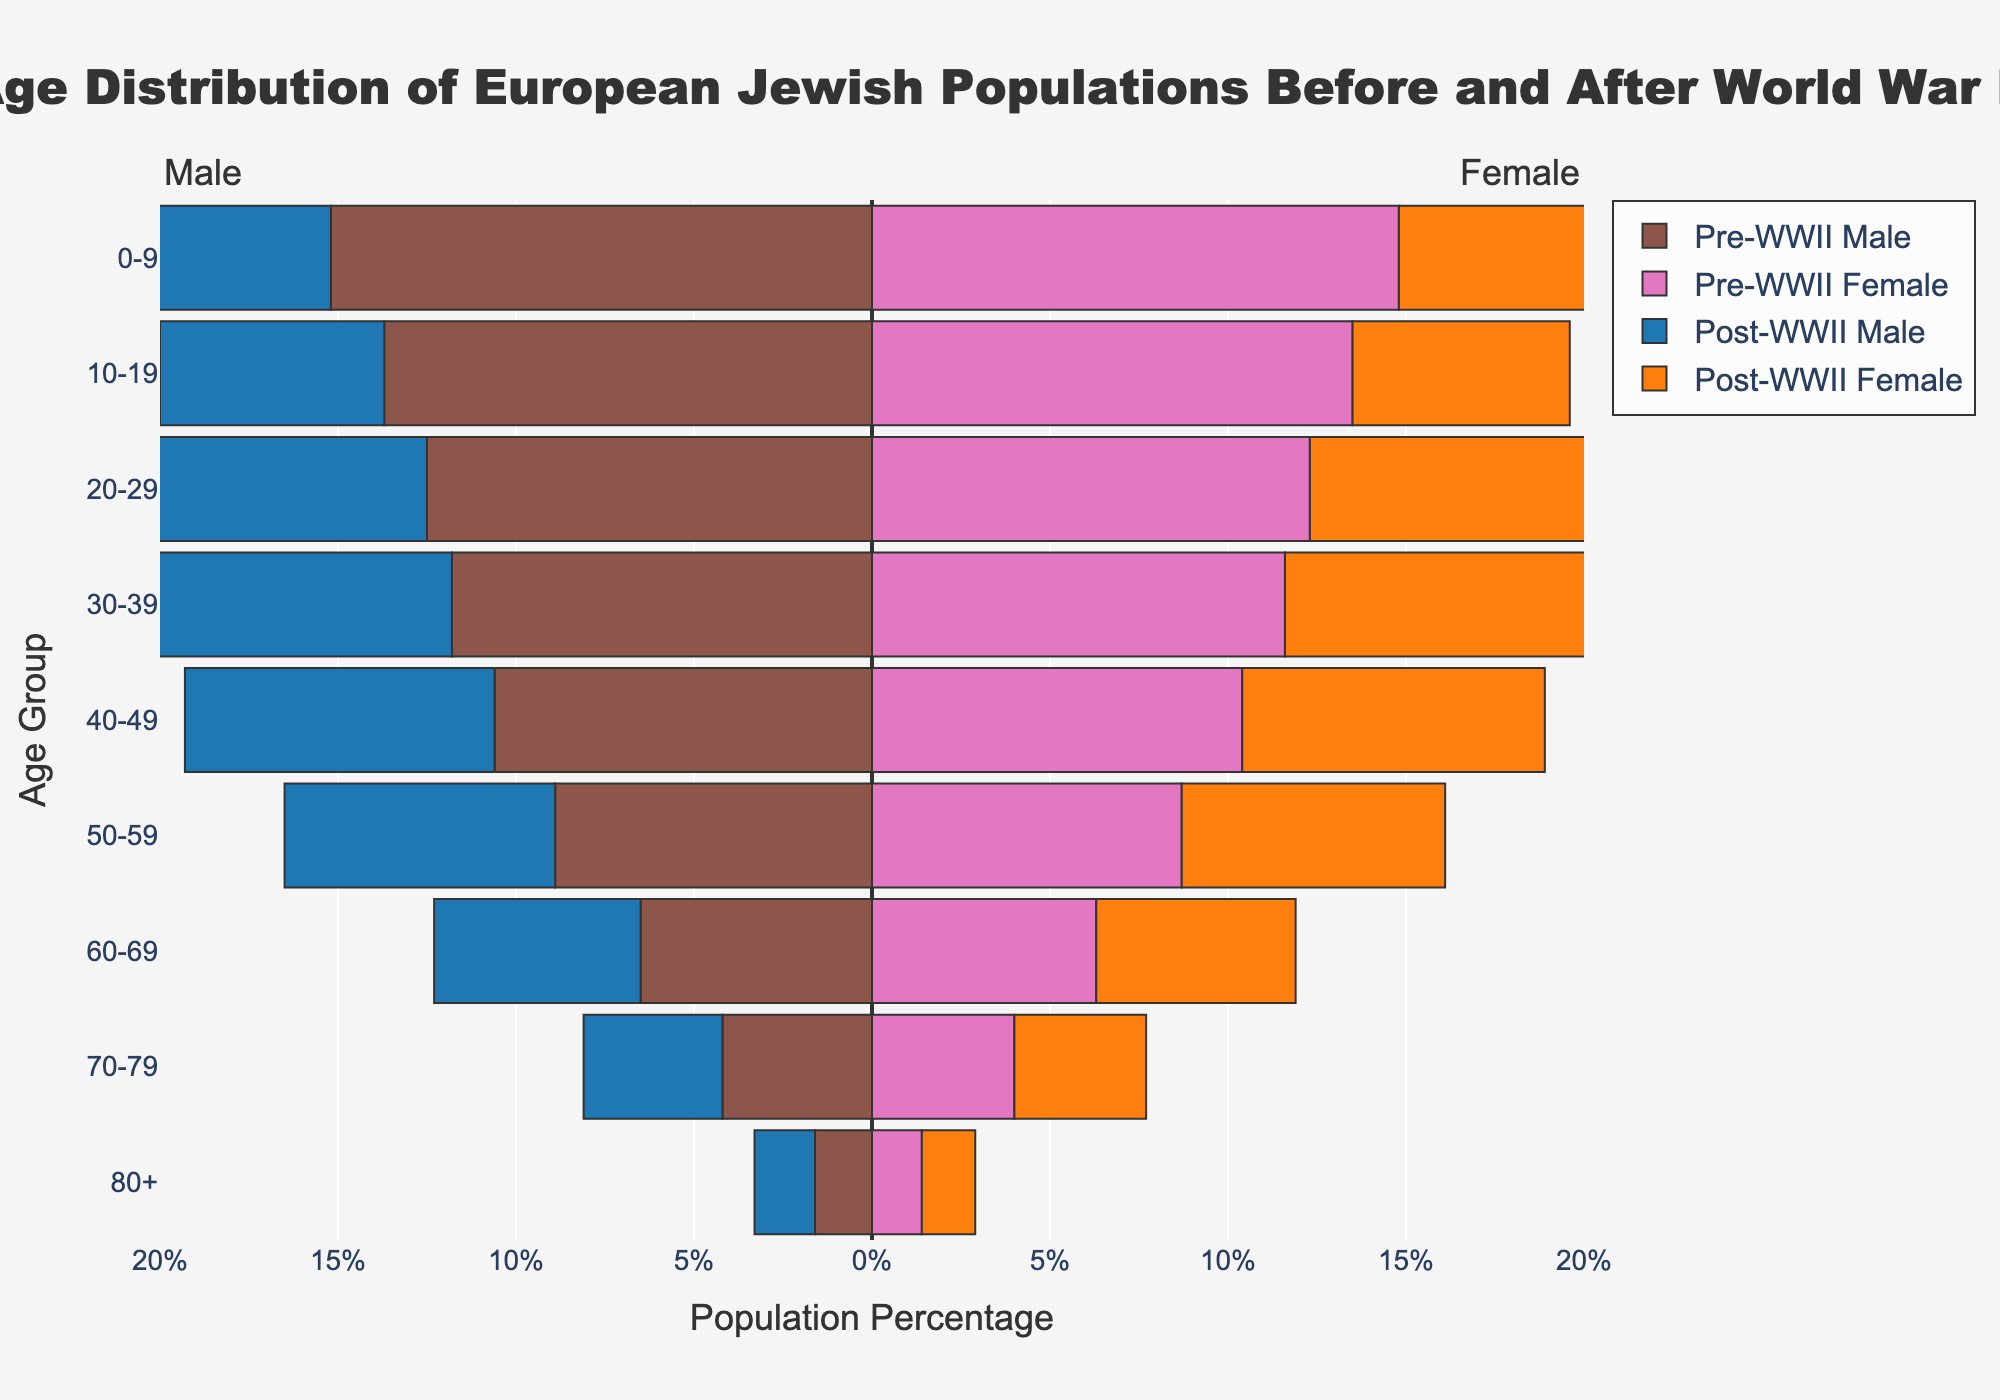What is the title of the plot? The title of the plot is located at the top of the figure. The text is in large font and should directly state what the figure represents.
Answer: Age Distribution of European Jewish Populations Before and After World War II What age group had the highest percentage of males before WWII? To determine the highest percentage of males before WWII, look at the horizontal bars representing "Pre-WWII Male" on the left side and find the one with the greatest magnitude (larger negative number).
Answer: 0-9 What is the percentage difference in the 0-9 age group between pre- and post-WWII males? First, find the percentage of males in the 0-9 age group pre-WWII (-15.2%) and post-WWII (-7.1%). Calculate the difference: 15.2% - 7.1% = 8.1%.
Answer: 8.1% How did the percentage of females in the 20-29 age group change from pre-WWII to post-WWII? Compare the percentage of females in the 20-29 age group pre-WWII (12.3%) to post-WWII (8%): 12.3% - 8% = 4.3% decrease.
Answer: Decreased by 4.3% Which gender and time period has the smallest proportion of individuals in the 70-79 age group? Check the 70-79 age group for all four categories (Pre-WWII Male, Pre-WWII Female, Post-WWII Male, and Post-WWII Female) and find the smallest percentage.
Answer: Pre-WWII Female How does the percentage of males aged 40-49 post-WWII compare to the percentage of females aged 40-49 post-WWII? Locate the percentages for males (8.7%) and females (8.5%) in the 40-49 age group post-WWII. Compare these values: 8.7% - 8.5% = 0.2% higher for males.
Answer: 0.2% higher What trend can be observed in the percentage of males in the population from the 0-9 age group to the 80+ age group pre-WWII? Observe the percentages of Pre-WWII Males in each age group from 0-9 (15.2%) to 80+ (1.6%). The trend shows a decrease in the percentage with increasing age.
Answer: Decreasing trend Which age group showed the least change in percentage for females before and after WWII? Compare the percentage change for each age group of females before and after WWII. Calculate the absolute differences: smallest difference indicates the least change.
Answer: 80+ age group What is the combined percentage of males and females in the 50-59 age group pre-WWII? Add the percentages for Pre-WWII Males (8.9%) and Pre-WWII Females (8.7%) in the 50-59 age group: 8.9% + 8.7% = 17.6%.
Answer: 17.6% Which age group had a higher post-WWII population distribution, males aged 30-39 or females aged 50-59? Compare the percentages: Post-WWII Males 30-39 (9.5%) and Post-WWII Females 50-59 (7.4%).
Answer: Males aged 30-39 